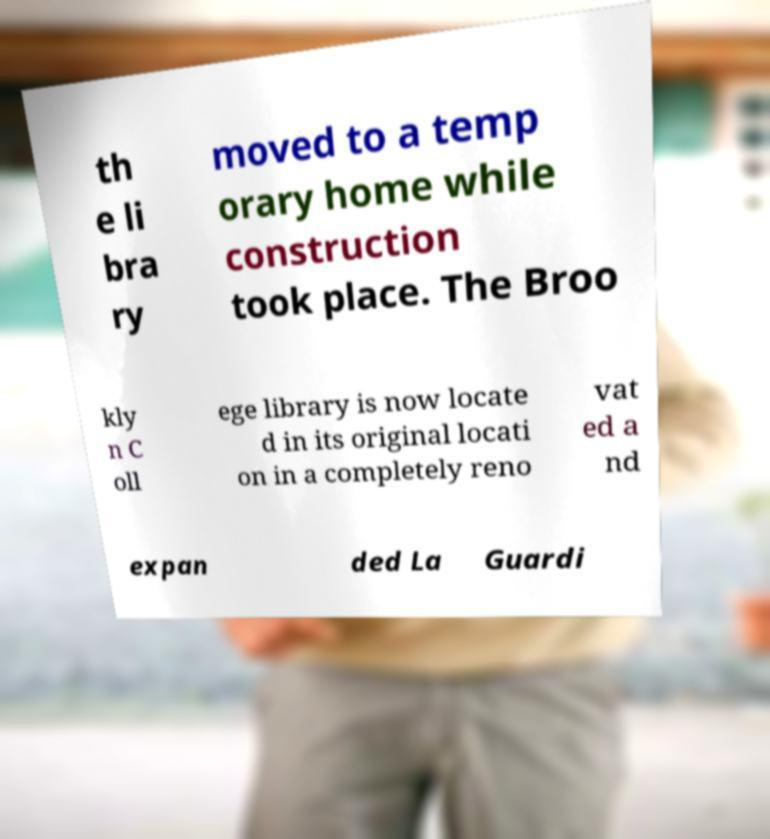I need the written content from this picture converted into text. Can you do that? th e li bra ry moved to a temp orary home while construction took place. The Broo kly n C oll ege library is now locate d in its original locati on in a completely reno vat ed a nd expan ded La Guardi 